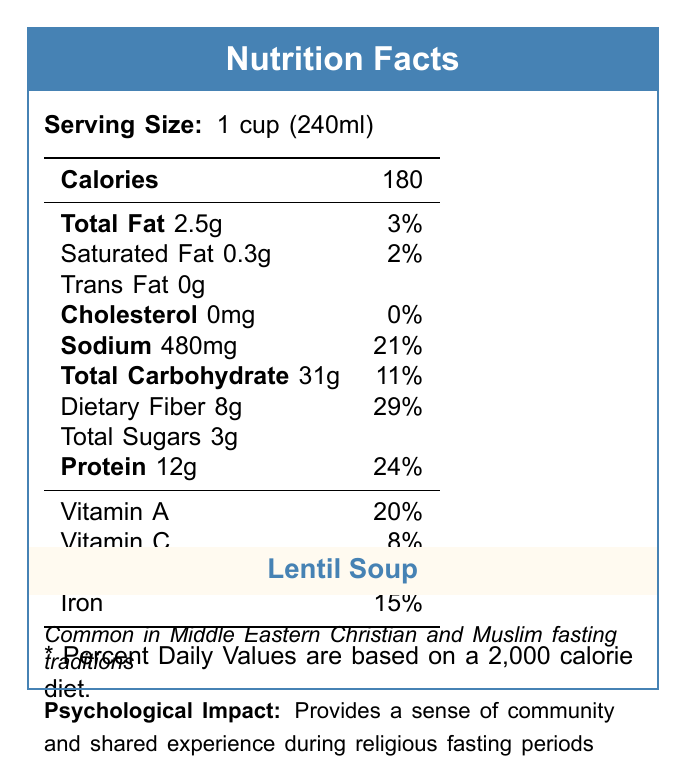What is the serving size of Lentil Soup? The document clearly states that the serving size of Lentil Soup is 1 cup (240ml).
Answer: 1 cup (240ml) How many calories does one serving of Lentil Soup contain? The document lists the calorie content of one serving of Lentil Soup as 180 calories.
Answer: 180 What is the total fat content in Lentil Soup? The total fat content mentioned in the document for one serving of Lentil Soup is 2.5g.
Answer: 2.5g How much dietary fiber does Lentil Soup provide per serving? According to the document, one serving of Lentil Soup provides 8g of dietary fiber.
Answer: 8g What percentage of the daily value of Iron does Lentil Soup contain? The document specifies that Lentil Soup contains 15% of the daily value of Iron.
Answer: 15% Which nutrients in Lentil Soup have a 0% daily value? A. Cholesterol B. Sodium C. Total Sugars D. Trans Fat The document shows that Lentil Soup has 0% daily value for Cholesterol and Trans Fat.
Answer: A. Cholesterol and D. Trans Fat How many grams of protein does Lentil Soup contain per serving? A. 5g B. 8g C. 12g D. 24g The document states that Lentil Soup contains 12g of protein per serving.
Answer: C. 12g Does Lentil Soup contain trans fat? The document indicates that there is 0g of trans fat in one serving of Lentil Soup.
Answer: No Summarize the psychological impact of consuming Lentil Soup. The document mentions that Lentil Soup is common in Middle Eastern Christian and Muslim fasting traditions and that it provides a sense of community and shared experience during religious fasting periods.
Answer: Provides a sense of community and shared experience during religious fasting periods. How much sodium is present in one serving of Lentil Soup? The document states that one serving of Lentil Soup contains 480mg of sodium.
Answer: 480mg Which vitamins are found in Lentil Soup, and what are their percentage daily values? The document lists Vitamin A and Vitamin C with their percentage daily values as 20% and 8%, respectively.
Answer: Vitamin A - 20%, Vitamin C - 8% Can Lentil Soup be considered a low-sodium food? The document states that Lentil Soup contains 480mg of sodium, which is 21% of the daily value, indicating it cannot be considered low in sodium.
Answer: No What is the main macronutrient providing energy in Lentil Soup? The document shows that Lentil Soup has 31g of carbohydrates, which is the primary macronutrient contributing to its energy content.
Answer: Carbohydrates What is the psychological impact of consuming Falafel according to the document? The document provided only describes the psychological impact of Lentil Soup.
Answer: Cannot be determined 